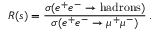<formula> <loc_0><loc_0><loc_500><loc_500>R ( s ) = { \frac { \sigma ( e ^ { + } e ^ { - } \to h a d r o n s ) } { \sigma ( e ^ { + } e ^ { - } \to \mu ^ { + } \mu ^ { - } ) } } \, .</formula> 